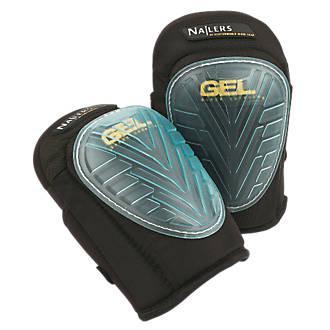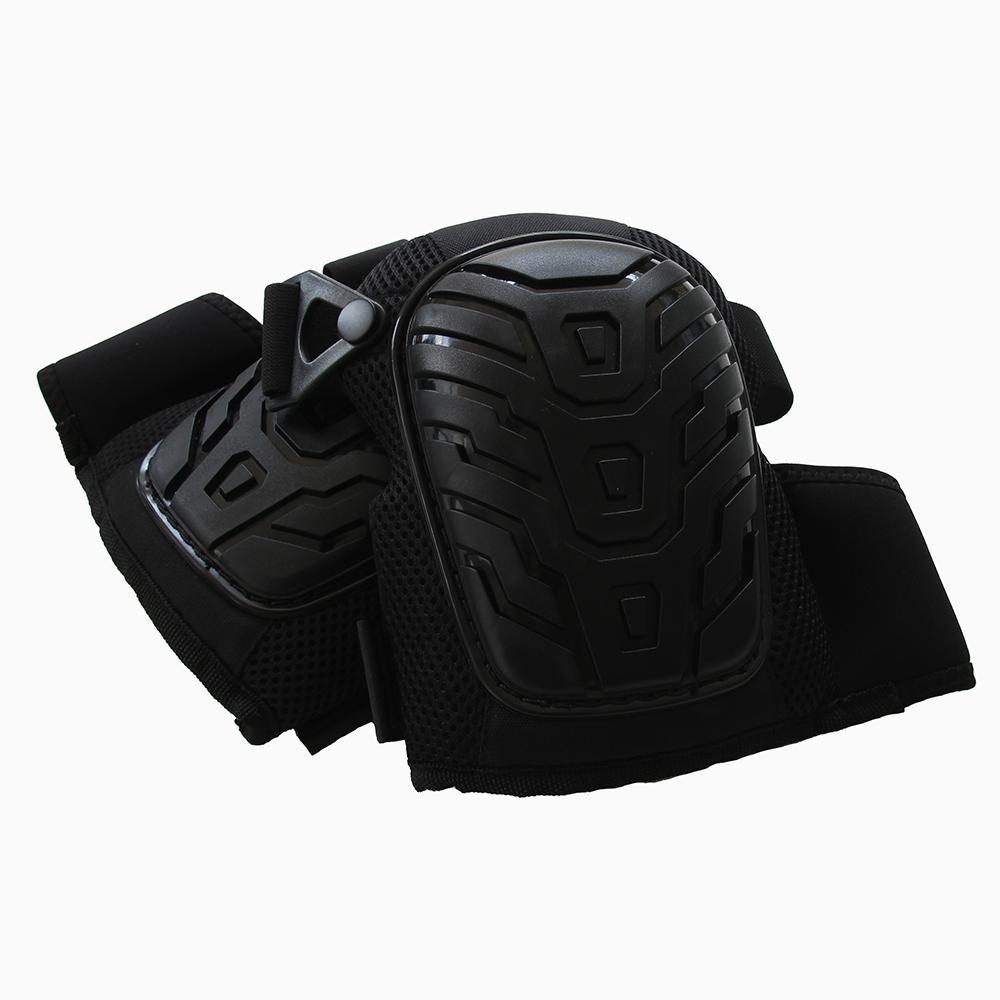The first image is the image on the left, the second image is the image on the right. Assess this claim about the two images: "The front and back side of one of the pads is visible.". Correct or not? Answer yes or no. No. 